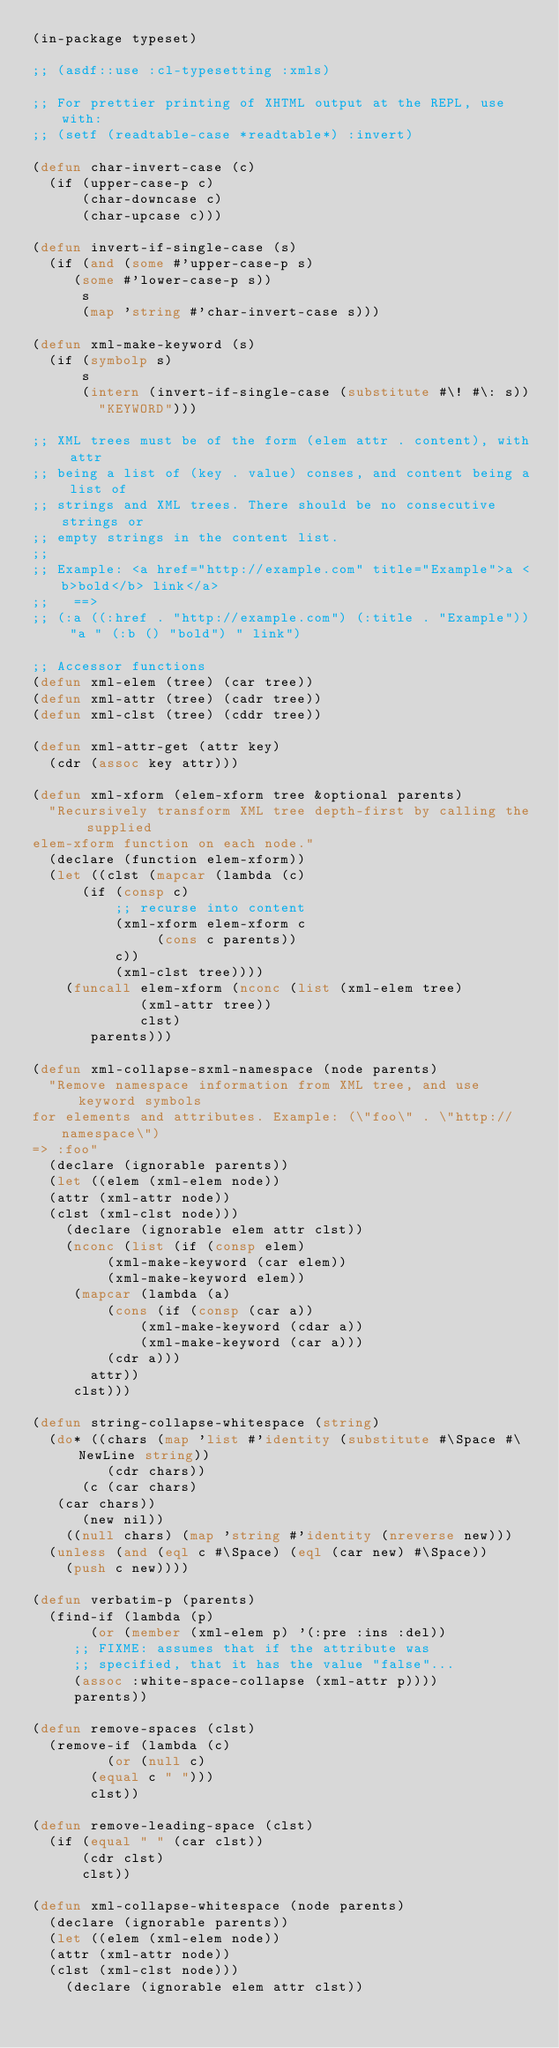<code> <loc_0><loc_0><loc_500><loc_500><_Lisp_>(in-package typeset)

;; (asdf::use :cl-typesetting :xmls)
 
;; For prettier printing of XHTML output at the REPL, use with:
;; (setf (readtable-case *readtable*) :invert)

(defun char-invert-case (c)
  (if (upper-case-p c)
      (char-downcase c)
      (char-upcase c)))

(defun invert-if-single-case (s)
  (if (and (some #'upper-case-p s)
	   (some #'lower-case-p s))
      s
      (map 'string #'char-invert-case s)))

(defun xml-make-keyword (s)
  (if (symbolp s)
      s
      (intern (invert-if-single-case (substitute #\! #\: s))
	      "KEYWORD")))

;; XML trees must be of the form (elem attr . content), with attr
;; being a list of (key . value) conses, and content being a list of
;; strings and XML trees. There should be no consecutive strings or
;; empty strings in the content list.
;;
;; Example: <a href="http://example.com" title="Example">a <b>bold</b> link</a>
;;   ==>    
;; (:a ((:href . "http://example.com") (:title . "Example")) "a " (:b () "bold") " link")

;; Accessor functions 
(defun xml-elem (tree) (car tree))
(defun xml-attr (tree) (cadr tree))
(defun xml-clst (tree) (cddr tree))

(defun xml-attr-get (attr key)
  (cdr (assoc key attr)))

(defun xml-xform (elem-xform tree &optional parents)
  "Recursively transform XML tree depth-first by calling the supplied
elem-xform function on each node."
  (declare (function elem-xform))
  (let ((clst (mapcar (lambda (c)
			(if (consp c)
			    ;; recurse into content
			    (xml-xform elem-xform c
				       (cons c parents))
			    c))
		      (xml-clst tree))))
    (funcall elem-xform (nconc (list (xml-elem tree)
				     (xml-attr tree))
			       clst)
	     parents)))

(defun xml-collapse-sxml-namespace (node parents)
  "Remove namespace information from XML tree, and use keyword symbols
for elements and attributes. Example: (\"foo\" . \"http://namespace\")
=> :foo"
  (declare (ignorable parents))
  (let ((elem (xml-elem node))
	(attr (xml-attr node))
	(clst (xml-clst node)))
    (declare (ignorable elem attr clst))
    (nconc (list (if (consp elem)
		     (xml-make-keyword (car elem))
		     (xml-make-keyword elem))
		 (mapcar (lambda (a)
			   (cons (if (consp (car a))
				     (xml-make-keyword (cdar a))
				     (xml-make-keyword (car a)))
				 (cdr a)))
			 attr))
	   clst)))

(defun string-collapse-whitespace (string)
  (do* ((chars (map 'list #'identity (substitute #\Space #\NewLine string))
	       (cdr chars))
      (c (car chars) 
	 (car chars))
      (new nil))
    ((null chars) (map 'string #'identity (nreverse new)))
  (unless (and (eql c #\Space) (eql (car new) #\Space))
    (push c new))))

(defun verbatim-p (parents)
  (find-if (lambda (p)
	     (or (member (xml-elem p) '(:pre :ins :del))
		 ;; FIXME: assumes that if the attribute was
		 ;; specified, that it has the value "false"...
		 (assoc :white-space-collapse (xml-attr p))))
	   parents))

(defun remove-spaces (clst)
  (remove-if (lambda (c)
	       (or (null c)
		   (equal c " ")))
	     clst))

(defun remove-leading-space (clst)
  (if (equal " " (car clst))
      (cdr clst)
      clst))

(defun xml-collapse-whitespace (node parents)
  (declare (ignorable parents))
  (let ((elem (xml-elem node))
	(attr (xml-attr node))
	(clst (xml-clst node)))
    (declare (ignorable elem attr clst))</code> 